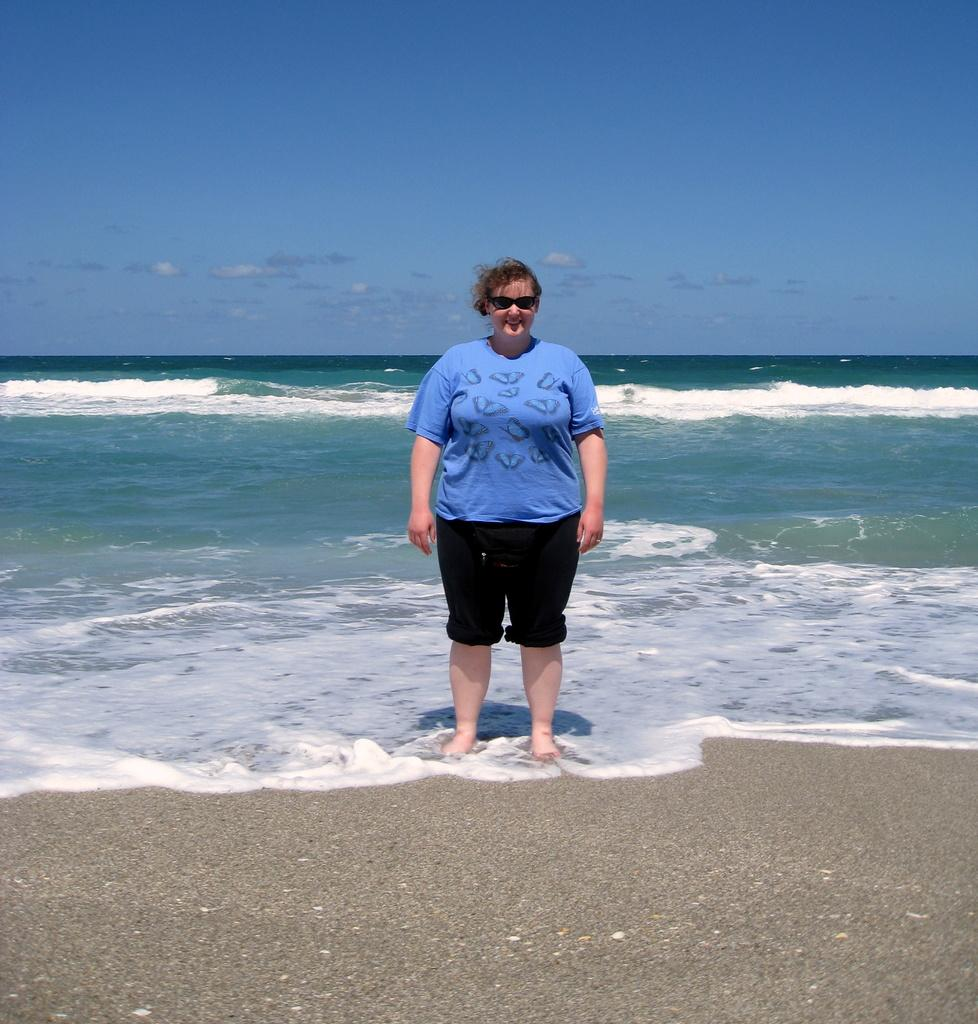What is the main subject of the image? There is a person in the image. Where is the person located? The person is standing on the sea shore. What type of voice can be heard coming from the cellar in the image? There is no cellar present in the image, and therefore no voice can be heard coming from it. 